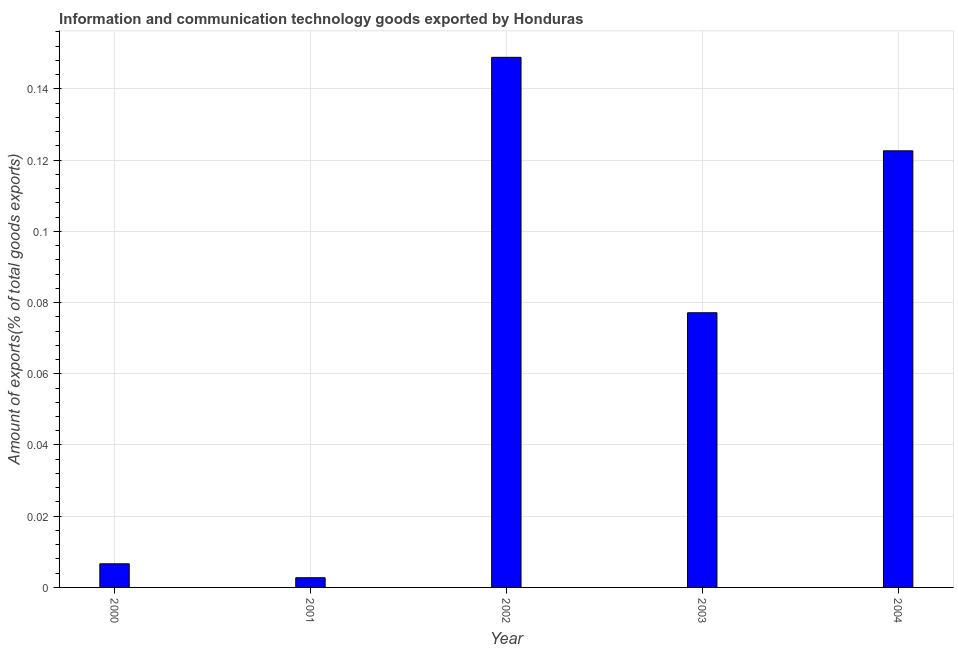What is the title of the graph?
Your answer should be compact. Information and communication technology goods exported by Honduras. What is the label or title of the Y-axis?
Make the answer very short. Amount of exports(% of total goods exports). What is the amount of ict goods exports in 2001?
Make the answer very short. 0. Across all years, what is the maximum amount of ict goods exports?
Your answer should be very brief. 0.15. Across all years, what is the minimum amount of ict goods exports?
Provide a short and direct response. 0. In which year was the amount of ict goods exports maximum?
Provide a succinct answer. 2002. In which year was the amount of ict goods exports minimum?
Provide a succinct answer. 2001. What is the sum of the amount of ict goods exports?
Provide a succinct answer. 0.36. What is the difference between the amount of ict goods exports in 2000 and 2002?
Keep it short and to the point. -0.14. What is the average amount of ict goods exports per year?
Give a very brief answer. 0.07. What is the median amount of ict goods exports?
Provide a succinct answer. 0.08. In how many years, is the amount of ict goods exports greater than 0.08 %?
Provide a succinct answer. 2. Do a majority of the years between 2002 and 2001 (inclusive) have amount of ict goods exports greater than 0.072 %?
Your answer should be compact. No. What is the ratio of the amount of ict goods exports in 2001 to that in 2003?
Your response must be concise. 0.04. Is the amount of ict goods exports in 2003 less than that in 2004?
Your answer should be very brief. Yes. What is the difference between the highest and the second highest amount of ict goods exports?
Make the answer very short. 0.03. What is the difference between the highest and the lowest amount of ict goods exports?
Offer a very short reply. 0.15. In how many years, is the amount of ict goods exports greater than the average amount of ict goods exports taken over all years?
Your answer should be compact. 3. Are all the bars in the graph horizontal?
Give a very brief answer. No. What is the difference between two consecutive major ticks on the Y-axis?
Your answer should be compact. 0.02. What is the Amount of exports(% of total goods exports) of 2000?
Your response must be concise. 0.01. What is the Amount of exports(% of total goods exports) in 2001?
Ensure brevity in your answer.  0. What is the Amount of exports(% of total goods exports) in 2002?
Your answer should be compact. 0.15. What is the Amount of exports(% of total goods exports) in 2003?
Ensure brevity in your answer.  0.08. What is the Amount of exports(% of total goods exports) of 2004?
Ensure brevity in your answer.  0.12. What is the difference between the Amount of exports(% of total goods exports) in 2000 and 2001?
Your answer should be very brief. 0. What is the difference between the Amount of exports(% of total goods exports) in 2000 and 2002?
Offer a terse response. -0.14. What is the difference between the Amount of exports(% of total goods exports) in 2000 and 2003?
Ensure brevity in your answer.  -0.07. What is the difference between the Amount of exports(% of total goods exports) in 2000 and 2004?
Your response must be concise. -0.12. What is the difference between the Amount of exports(% of total goods exports) in 2001 and 2002?
Your response must be concise. -0.15. What is the difference between the Amount of exports(% of total goods exports) in 2001 and 2003?
Provide a short and direct response. -0.07. What is the difference between the Amount of exports(% of total goods exports) in 2001 and 2004?
Your answer should be very brief. -0.12. What is the difference between the Amount of exports(% of total goods exports) in 2002 and 2003?
Keep it short and to the point. 0.07. What is the difference between the Amount of exports(% of total goods exports) in 2002 and 2004?
Offer a terse response. 0.03. What is the difference between the Amount of exports(% of total goods exports) in 2003 and 2004?
Your answer should be very brief. -0.05. What is the ratio of the Amount of exports(% of total goods exports) in 2000 to that in 2001?
Offer a terse response. 2.44. What is the ratio of the Amount of exports(% of total goods exports) in 2000 to that in 2002?
Provide a succinct answer. 0.04. What is the ratio of the Amount of exports(% of total goods exports) in 2000 to that in 2003?
Make the answer very short. 0.09. What is the ratio of the Amount of exports(% of total goods exports) in 2000 to that in 2004?
Your response must be concise. 0.05. What is the ratio of the Amount of exports(% of total goods exports) in 2001 to that in 2002?
Make the answer very short. 0.02. What is the ratio of the Amount of exports(% of total goods exports) in 2001 to that in 2003?
Offer a very short reply. 0.04. What is the ratio of the Amount of exports(% of total goods exports) in 2001 to that in 2004?
Your response must be concise. 0.02. What is the ratio of the Amount of exports(% of total goods exports) in 2002 to that in 2003?
Provide a succinct answer. 1.93. What is the ratio of the Amount of exports(% of total goods exports) in 2002 to that in 2004?
Your answer should be very brief. 1.21. What is the ratio of the Amount of exports(% of total goods exports) in 2003 to that in 2004?
Your answer should be compact. 0.63. 